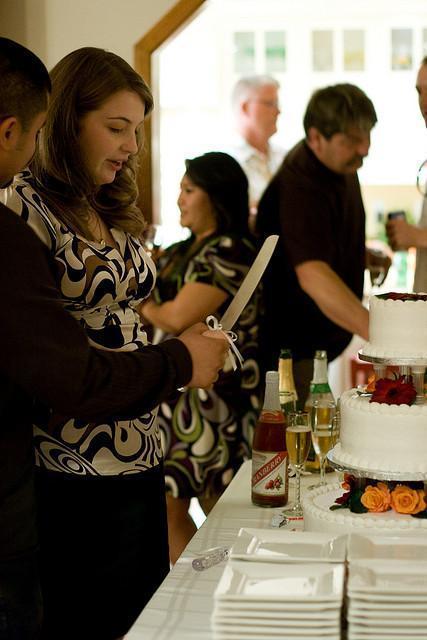How many bottles are on table?
Give a very brief answer. 3. How many layer on this cake?
Give a very brief answer. 2. How many people can be seen?
Give a very brief answer. 6. How many cakes are visible?
Give a very brief answer. 3. How many cups are on the table?
Give a very brief answer. 0. 